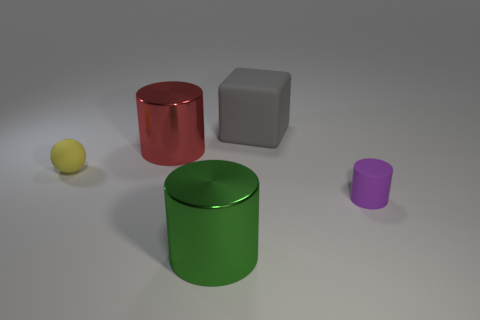Add 3 small blue shiny blocks. How many objects exist? 8 Subtract all cubes. How many objects are left? 4 Subtract all red objects. Subtract all tiny purple things. How many objects are left? 3 Add 3 big red things. How many big red things are left? 4 Add 5 red matte cubes. How many red matte cubes exist? 5 Subtract 0 cyan cubes. How many objects are left? 5 